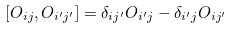<formula> <loc_0><loc_0><loc_500><loc_500>[ O _ { i j } , O _ { i ^ { \prime } j ^ { \prime } } ] = \delta _ { i j ^ { \prime } } O _ { i ^ { \prime } j } - \delta _ { i ^ { \prime } j } O _ { i j ^ { \prime } }</formula> 